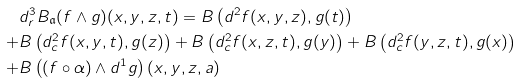Convert formula to latex. <formula><loc_0><loc_0><loc_500><loc_500>& d ^ { 3 } _ { r } B _ { \mathfrak a } ( f \wedge g ) ( x , y , z , t ) = B \left ( d ^ { 2 } f ( x , y , z ) , g ( t ) \right ) \\ + & B \left ( d ^ { 2 } _ { c } f ( x , y , t ) , g ( z ) \right ) + B \left ( d ^ { 2 } _ { c } f ( x , z , t ) , g ( y ) \right ) + B \left ( d ^ { 2 } _ { c } f ( y , z , t ) , g ( x ) \right ) \\ + & B \left ( ( f \circ \alpha ) \wedge d ^ { 1 } g \right ) ( x , y , z , a )</formula> 